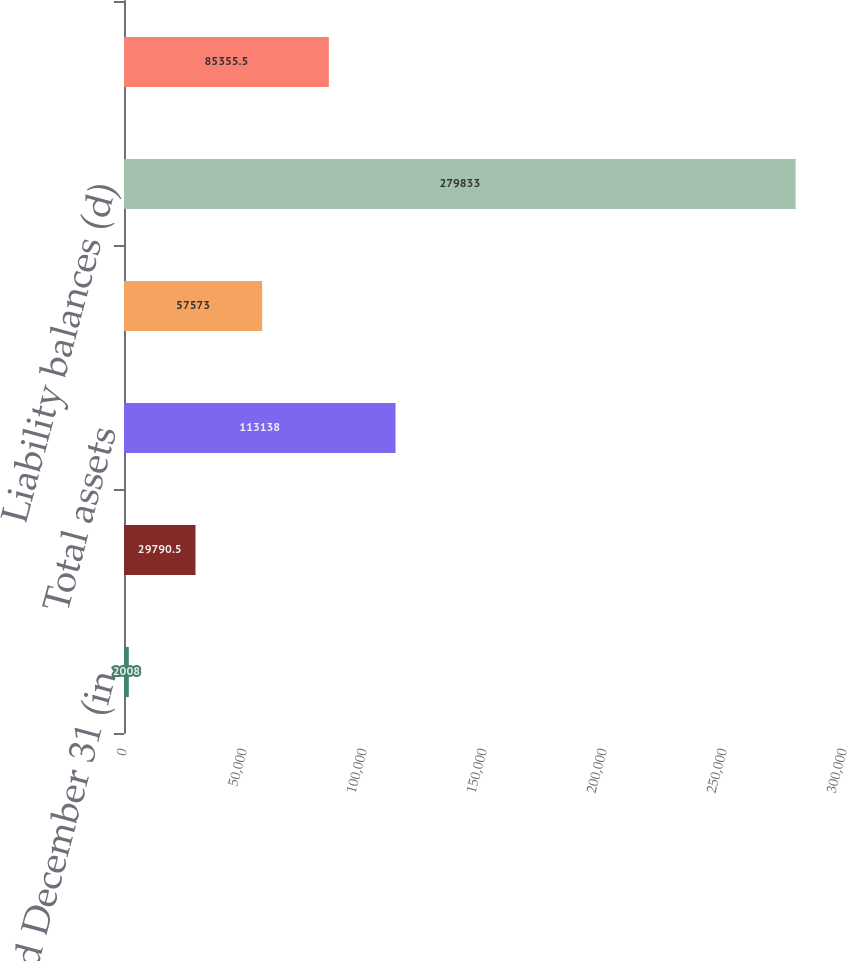Convert chart. <chart><loc_0><loc_0><loc_500><loc_500><bar_chart><fcel>Year ended December 31 (in<fcel>Equity<fcel>Total assets<fcel>Loans (c)<fcel>Liability balances (d)<fcel>Headcount<nl><fcel>2008<fcel>29790.5<fcel>113138<fcel>57573<fcel>279833<fcel>85355.5<nl></chart> 